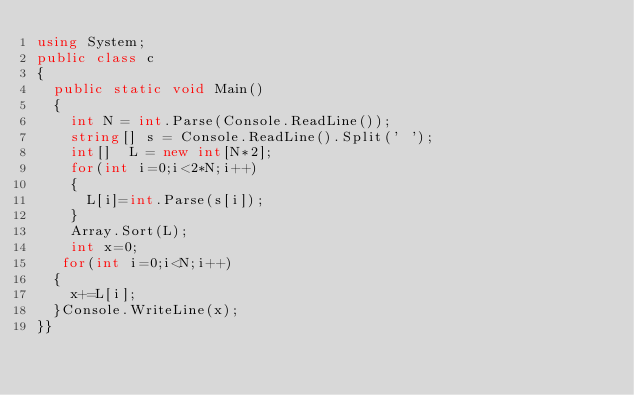<code> <loc_0><loc_0><loc_500><loc_500><_C#_>using System;
public class c
{
  public static void Main()
  {
    int N = int.Parse(Console.ReadLine());
    string[] s = Console.ReadLine().Split(' ');
    int[]  L = new int[N*2];
    for(int i=0;i<2*N;i++)
    {
      L[i]=int.Parse(s[i]);
    }
    Array.Sort(L);
    int x=0;
   for(int i=0;i<N;i++)
  {
    x+=L[i];
  }Console.WriteLine(x);
}}</code> 